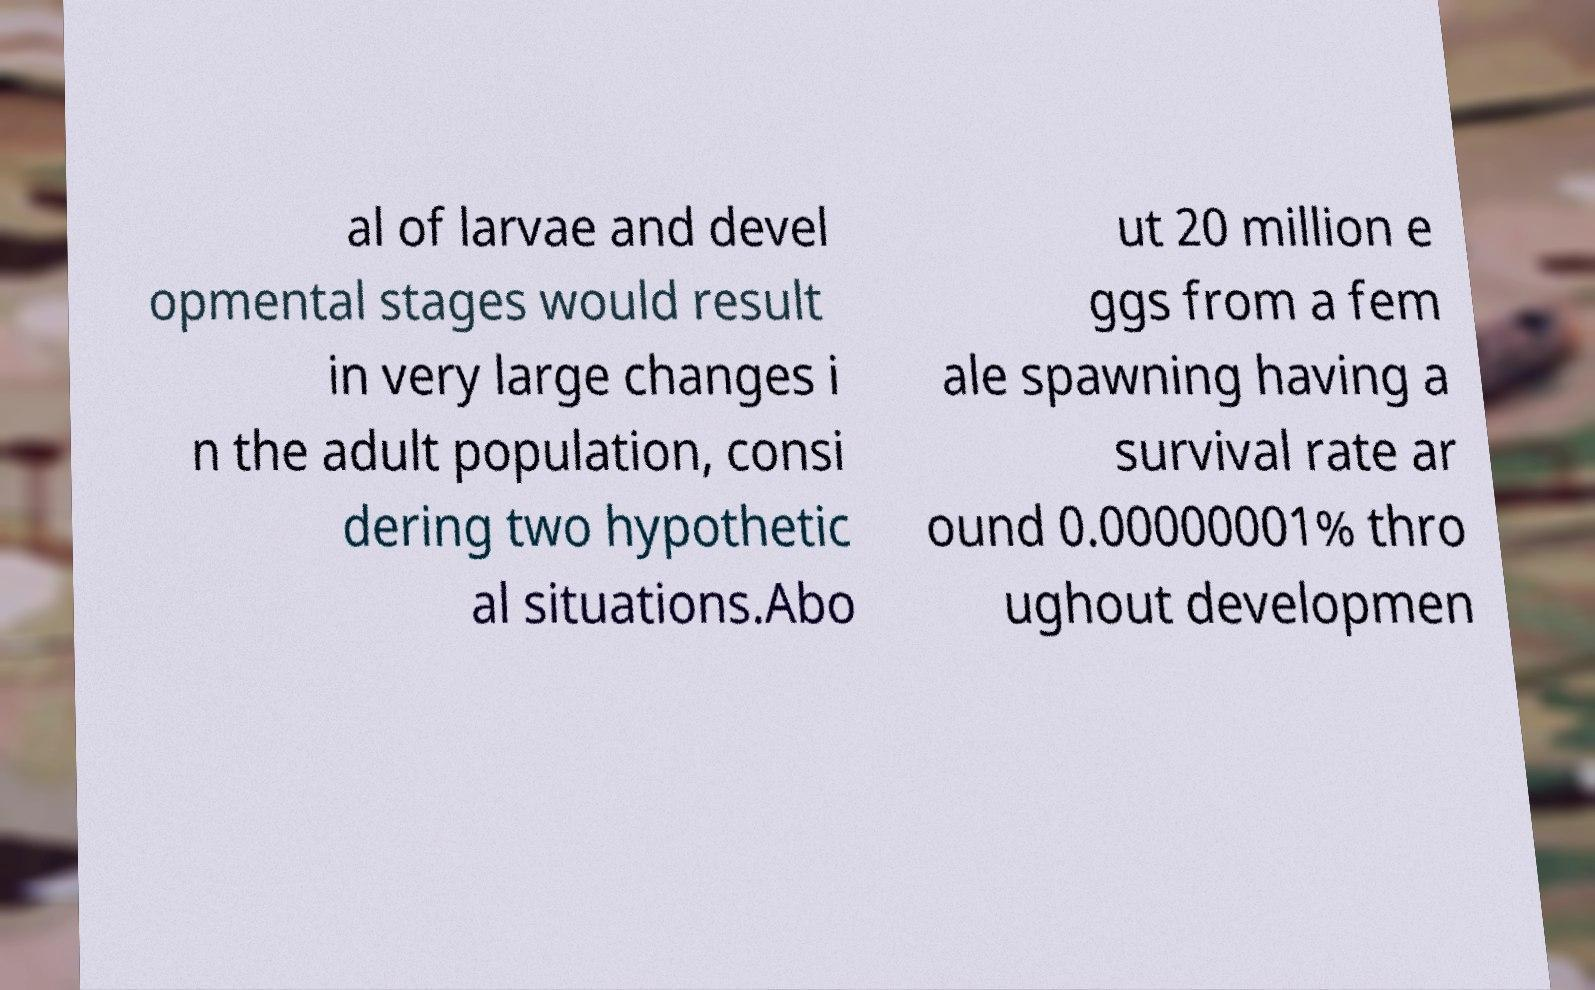Please read and relay the text visible in this image. What does it say? al of larvae and devel opmental stages would result in very large changes i n the adult population, consi dering two hypothetic al situations.Abo ut 20 million e ggs from a fem ale spawning having a survival rate ar ound 0.00000001% thro ughout developmen 